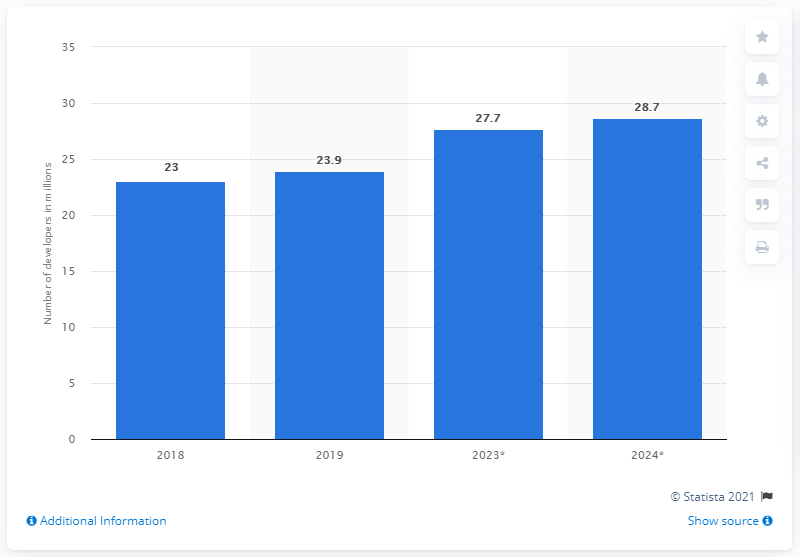Mention a couple of crucial points in this snapshot. By the year 2024, it is projected that the global developer population will reach 28.7 billion. 